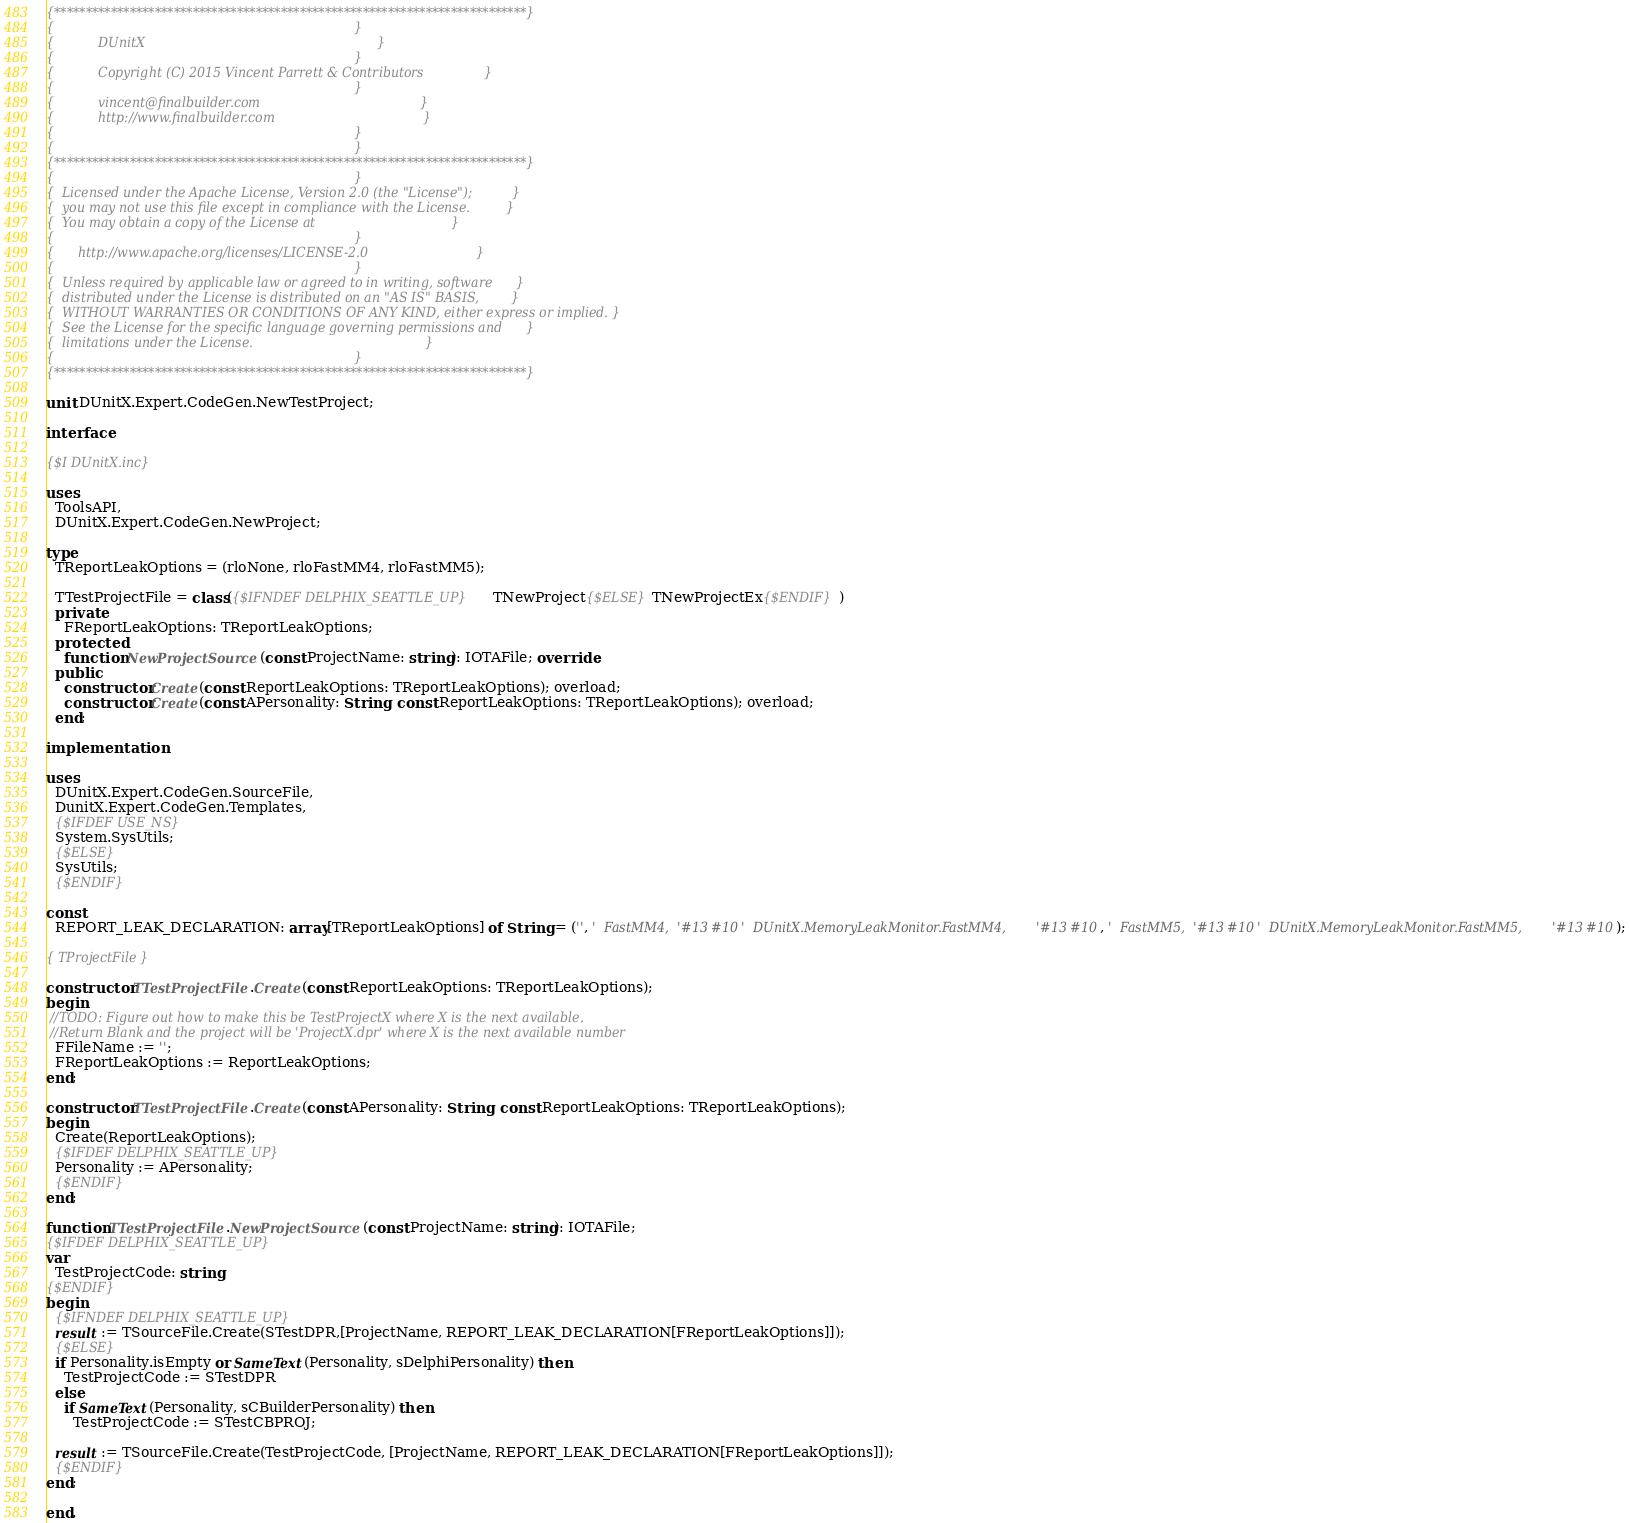<code> <loc_0><loc_0><loc_500><loc_500><_Pascal_>{***************************************************************************}
{                                                                           }
{           DUnitX                                                          }
{                                                                           }
{           Copyright (C) 2015 Vincent Parrett & Contributors               }
{                                                                           }
{           vincent@finalbuilder.com                                        }
{           http://www.finalbuilder.com                                     }
{                                                                           }
{                                                                           }
{***************************************************************************}
{                                                                           }
{  Licensed under the Apache License, Version 2.0 (the "License");          }
{  you may not use this file except in compliance with the License.         }
{  You may obtain a copy of the License at                                  }
{                                                                           }
{      http://www.apache.org/licenses/LICENSE-2.0                           }
{                                                                           }
{  Unless required by applicable law or agreed to in writing, software      }
{  distributed under the License is distributed on an "AS IS" BASIS,        }
{  WITHOUT WARRANTIES OR CONDITIONS OF ANY KIND, either express or implied. }
{  See the License for the specific language governing permissions and      }
{  limitations under the License.                                           }
{                                                                           }
{***************************************************************************}

unit DUnitX.Expert.CodeGen.NewTestProject;

interface

{$I DUnitX.inc}

uses
  ToolsAPI,
  DUnitX.Expert.CodeGen.NewProject;

type
  TReportLeakOptions = (rloNone, rloFastMM4, rloFastMM5);

  TTestProjectFile = class({$IFNDEF DELPHIX_SEATTLE_UP}TNewProject{$ELSE}TNewProjectEx{$ENDIF})
  private
    FReportLeakOptions: TReportLeakOptions;
  protected
    function NewProjectSource(const ProjectName: string): IOTAFile; override;
  public
    constructor Create(const ReportLeakOptions: TReportLeakOptions); overload;
    constructor Create(const APersonality: String; const ReportLeakOptions: TReportLeakOptions); overload;
  end;

implementation

uses
  DUnitX.Expert.CodeGen.SourceFile,
  DunitX.Expert.CodeGen.Templates,
  {$IFDEF USE_NS}
  System.SysUtils;
  {$ELSE}
  SysUtils;
  {$ENDIF}

const
  REPORT_LEAK_DECLARATION: array[TReportLeakOptions] of String = ('', '  FastMM4,'#13#10'  DUnitX.MemoryLeakMonitor.FastMM4,'#13#10, '  FastMM5,'#13#10'  DUnitX.MemoryLeakMonitor.FastMM5,'#13#10);

{ TProjectFile }

constructor TTestProjectFile.Create(const ReportLeakOptions: TReportLeakOptions);
begin
 //TODO: Figure out how to make this be TestProjectX where X is the next available.
 //Return Blank and the project will be 'ProjectX.dpr' where X is the next available number
  FFileName := '';
  FReportLeakOptions := ReportLeakOptions;
end;

constructor TTestProjectFile.Create(const APersonality: String; const ReportLeakOptions: TReportLeakOptions);
begin
  Create(ReportLeakOptions);
  {$IFDEF DELPHIX_SEATTLE_UP}
  Personality := APersonality;
  {$ENDIF}
end;

function TTestProjectFile.NewProjectSource(const ProjectName: string): IOTAFile;
{$IFDEF DELPHIX_SEATTLE_UP}
var
  TestProjectCode: string;
{$ENDIF}
begin
  {$IFNDEF DELPHIX_SEATTLE_UP}
  result := TSourceFile.Create(STestDPR,[ProjectName, REPORT_LEAK_DECLARATION[FReportLeakOptions]]);
  {$ELSE}
  if Personality.isEmpty or SameText(Personality, sDelphiPersonality) then
    TestProjectCode := STestDPR
  else
    if SameText(Personality, sCBuilderPersonality) then
      TestProjectCode := STestCBPROJ;

  result := TSourceFile.Create(TestProjectCode, [ProjectName, REPORT_LEAK_DECLARATION[FReportLeakOptions]]);
  {$ENDIF}
end;

end.
</code> 